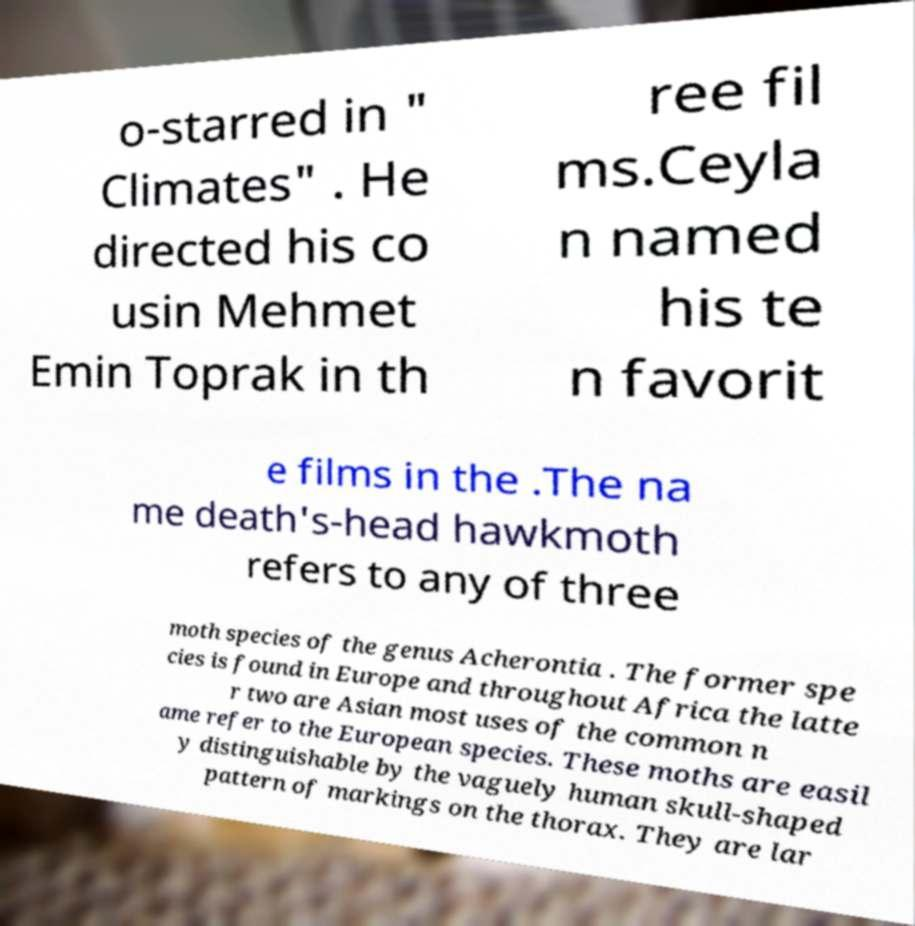Please identify and transcribe the text found in this image. o-starred in " Climates" . He directed his co usin Mehmet Emin Toprak in th ree fil ms.Ceyla n named his te n favorit e films in the .The na me death's-head hawkmoth refers to any of three moth species of the genus Acherontia . The former spe cies is found in Europe and throughout Africa the latte r two are Asian most uses of the common n ame refer to the European species. These moths are easil y distinguishable by the vaguely human skull-shaped pattern of markings on the thorax. They are lar 